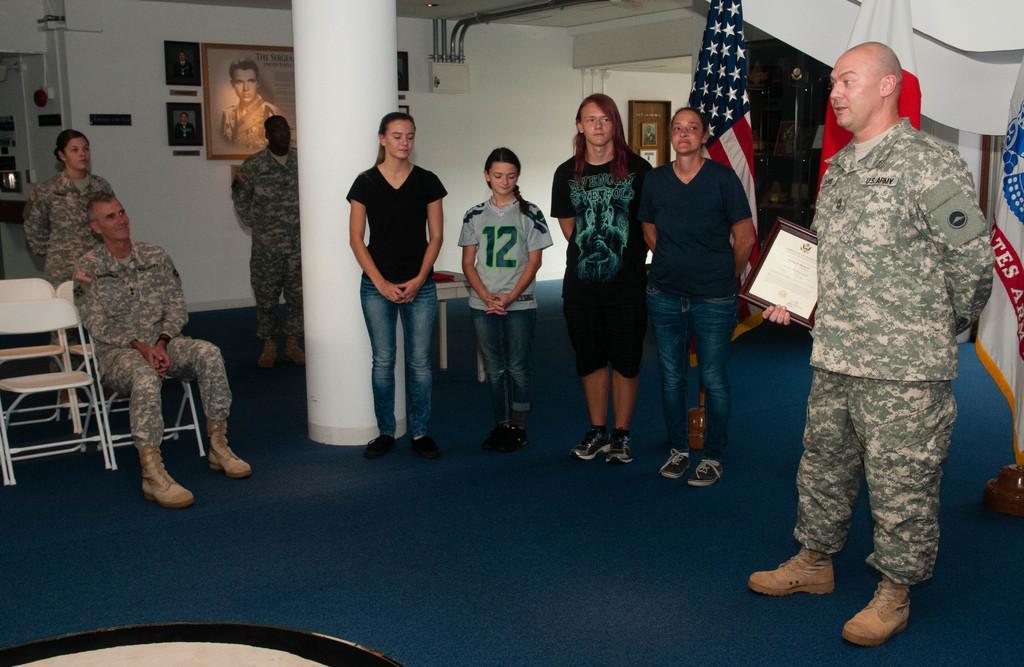How would you summarize this image in a sentence or two? In this image we can see people standing. To the left side of the image there is a person sitting on a chair. In the background of the image there is a wall. There is a photo frame. To the right side of the image there are flags. At the bottom of the image there is carpet. 